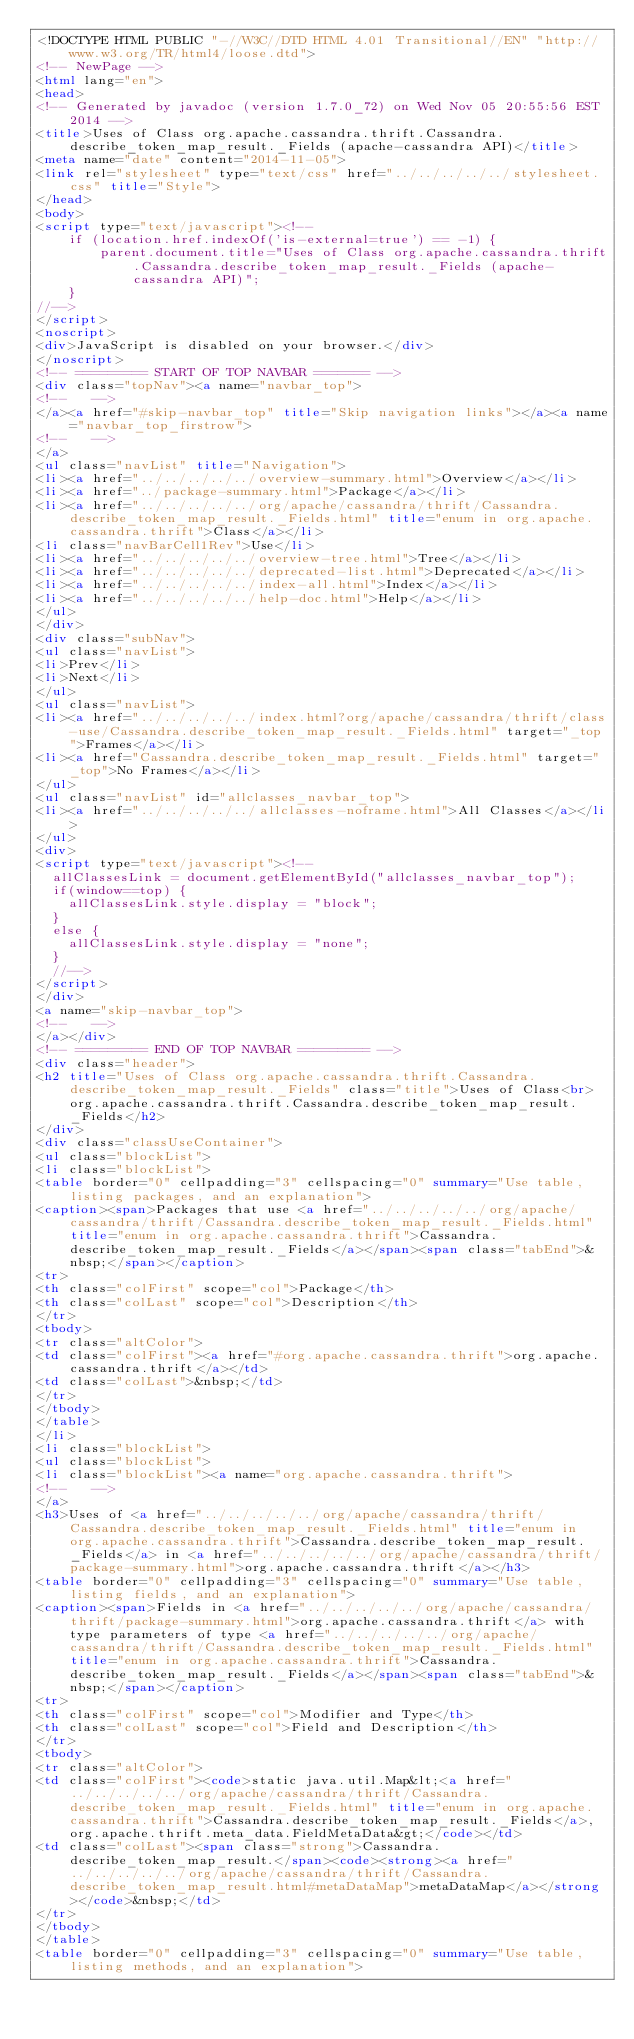Convert code to text. <code><loc_0><loc_0><loc_500><loc_500><_HTML_><!DOCTYPE HTML PUBLIC "-//W3C//DTD HTML 4.01 Transitional//EN" "http://www.w3.org/TR/html4/loose.dtd">
<!-- NewPage -->
<html lang="en">
<head>
<!-- Generated by javadoc (version 1.7.0_72) on Wed Nov 05 20:55:56 EST 2014 -->
<title>Uses of Class org.apache.cassandra.thrift.Cassandra.describe_token_map_result._Fields (apache-cassandra API)</title>
<meta name="date" content="2014-11-05">
<link rel="stylesheet" type="text/css" href="../../../../../stylesheet.css" title="Style">
</head>
<body>
<script type="text/javascript"><!--
    if (location.href.indexOf('is-external=true') == -1) {
        parent.document.title="Uses of Class org.apache.cassandra.thrift.Cassandra.describe_token_map_result._Fields (apache-cassandra API)";
    }
//-->
</script>
<noscript>
<div>JavaScript is disabled on your browser.</div>
</noscript>
<!-- ========= START OF TOP NAVBAR ======= -->
<div class="topNav"><a name="navbar_top">
<!--   -->
</a><a href="#skip-navbar_top" title="Skip navigation links"></a><a name="navbar_top_firstrow">
<!--   -->
</a>
<ul class="navList" title="Navigation">
<li><a href="../../../../../overview-summary.html">Overview</a></li>
<li><a href="../package-summary.html">Package</a></li>
<li><a href="../../../../../org/apache/cassandra/thrift/Cassandra.describe_token_map_result._Fields.html" title="enum in org.apache.cassandra.thrift">Class</a></li>
<li class="navBarCell1Rev">Use</li>
<li><a href="../../../../../overview-tree.html">Tree</a></li>
<li><a href="../../../../../deprecated-list.html">Deprecated</a></li>
<li><a href="../../../../../index-all.html">Index</a></li>
<li><a href="../../../../../help-doc.html">Help</a></li>
</ul>
</div>
<div class="subNav">
<ul class="navList">
<li>Prev</li>
<li>Next</li>
</ul>
<ul class="navList">
<li><a href="../../../../../index.html?org/apache/cassandra/thrift/class-use/Cassandra.describe_token_map_result._Fields.html" target="_top">Frames</a></li>
<li><a href="Cassandra.describe_token_map_result._Fields.html" target="_top">No Frames</a></li>
</ul>
<ul class="navList" id="allclasses_navbar_top">
<li><a href="../../../../../allclasses-noframe.html">All Classes</a></li>
</ul>
<div>
<script type="text/javascript"><!--
  allClassesLink = document.getElementById("allclasses_navbar_top");
  if(window==top) {
    allClassesLink.style.display = "block";
  }
  else {
    allClassesLink.style.display = "none";
  }
  //-->
</script>
</div>
<a name="skip-navbar_top">
<!--   -->
</a></div>
<!-- ========= END OF TOP NAVBAR ========= -->
<div class="header">
<h2 title="Uses of Class org.apache.cassandra.thrift.Cassandra.describe_token_map_result._Fields" class="title">Uses of Class<br>org.apache.cassandra.thrift.Cassandra.describe_token_map_result._Fields</h2>
</div>
<div class="classUseContainer">
<ul class="blockList">
<li class="blockList">
<table border="0" cellpadding="3" cellspacing="0" summary="Use table, listing packages, and an explanation">
<caption><span>Packages that use <a href="../../../../../org/apache/cassandra/thrift/Cassandra.describe_token_map_result._Fields.html" title="enum in org.apache.cassandra.thrift">Cassandra.describe_token_map_result._Fields</a></span><span class="tabEnd">&nbsp;</span></caption>
<tr>
<th class="colFirst" scope="col">Package</th>
<th class="colLast" scope="col">Description</th>
</tr>
<tbody>
<tr class="altColor">
<td class="colFirst"><a href="#org.apache.cassandra.thrift">org.apache.cassandra.thrift</a></td>
<td class="colLast">&nbsp;</td>
</tr>
</tbody>
</table>
</li>
<li class="blockList">
<ul class="blockList">
<li class="blockList"><a name="org.apache.cassandra.thrift">
<!--   -->
</a>
<h3>Uses of <a href="../../../../../org/apache/cassandra/thrift/Cassandra.describe_token_map_result._Fields.html" title="enum in org.apache.cassandra.thrift">Cassandra.describe_token_map_result._Fields</a> in <a href="../../../../../org/apache/cassandra/thrift/package-summary.html">org.apache.cassandra.thrift</a></h3>
<table border="0" cellpadding="3" cellspacing="0" summary="Use table, listing fields, and an explanation">
<caption><span>Fields in <a href="../../../../../org/apache/cassandra/thrift/package-summary.html">org.apache.cassandra.thrift</a> with type parameters of type <a href="../../../../../org/apache/cassandra/thrift/Cassandra.describe_token_map_result._Fields.html" title="enum in org.apache.cassandra.thrift">Cassandra.describe_token_map_result._Fields</a></span><span class="tabEnd">&nbsp;</span></caption>
<tr>
<th class="colFirst" scope="col">Modifier and Type</th>
<th class="colLast" scope="col">Field and Description</th>
</tr>
<tbody>
<tr class="altColor">
<td class="colFirst"><code>static java.util.Map&lt;<a href="../../../../../org/apache/cassandra/thrift/Cassandra.describe_token_map_result._Fields.html" title="enum in org.apache.cassandra.thrift">Cassandra.describe_token_map_result._Fields</a>,org.apache.thrift.meta_data.FieldMetaData&gt;</code></td>
<td class="colLast"><span class="strong">Cassandra.describe_token_map_result.</span><code><strong><a href="../../../../../org/apache/cassandra/thrift/Cassandra.describe_token_map_result.html#metaDataMap">metaDataMap</a></strong></code>&nbsp;</td>
</tr>
</tbody>
</table>
<table border="0" cellpadding="3" cellspacing="0" summary="Use table, listing methods, and an explanation"></code> 